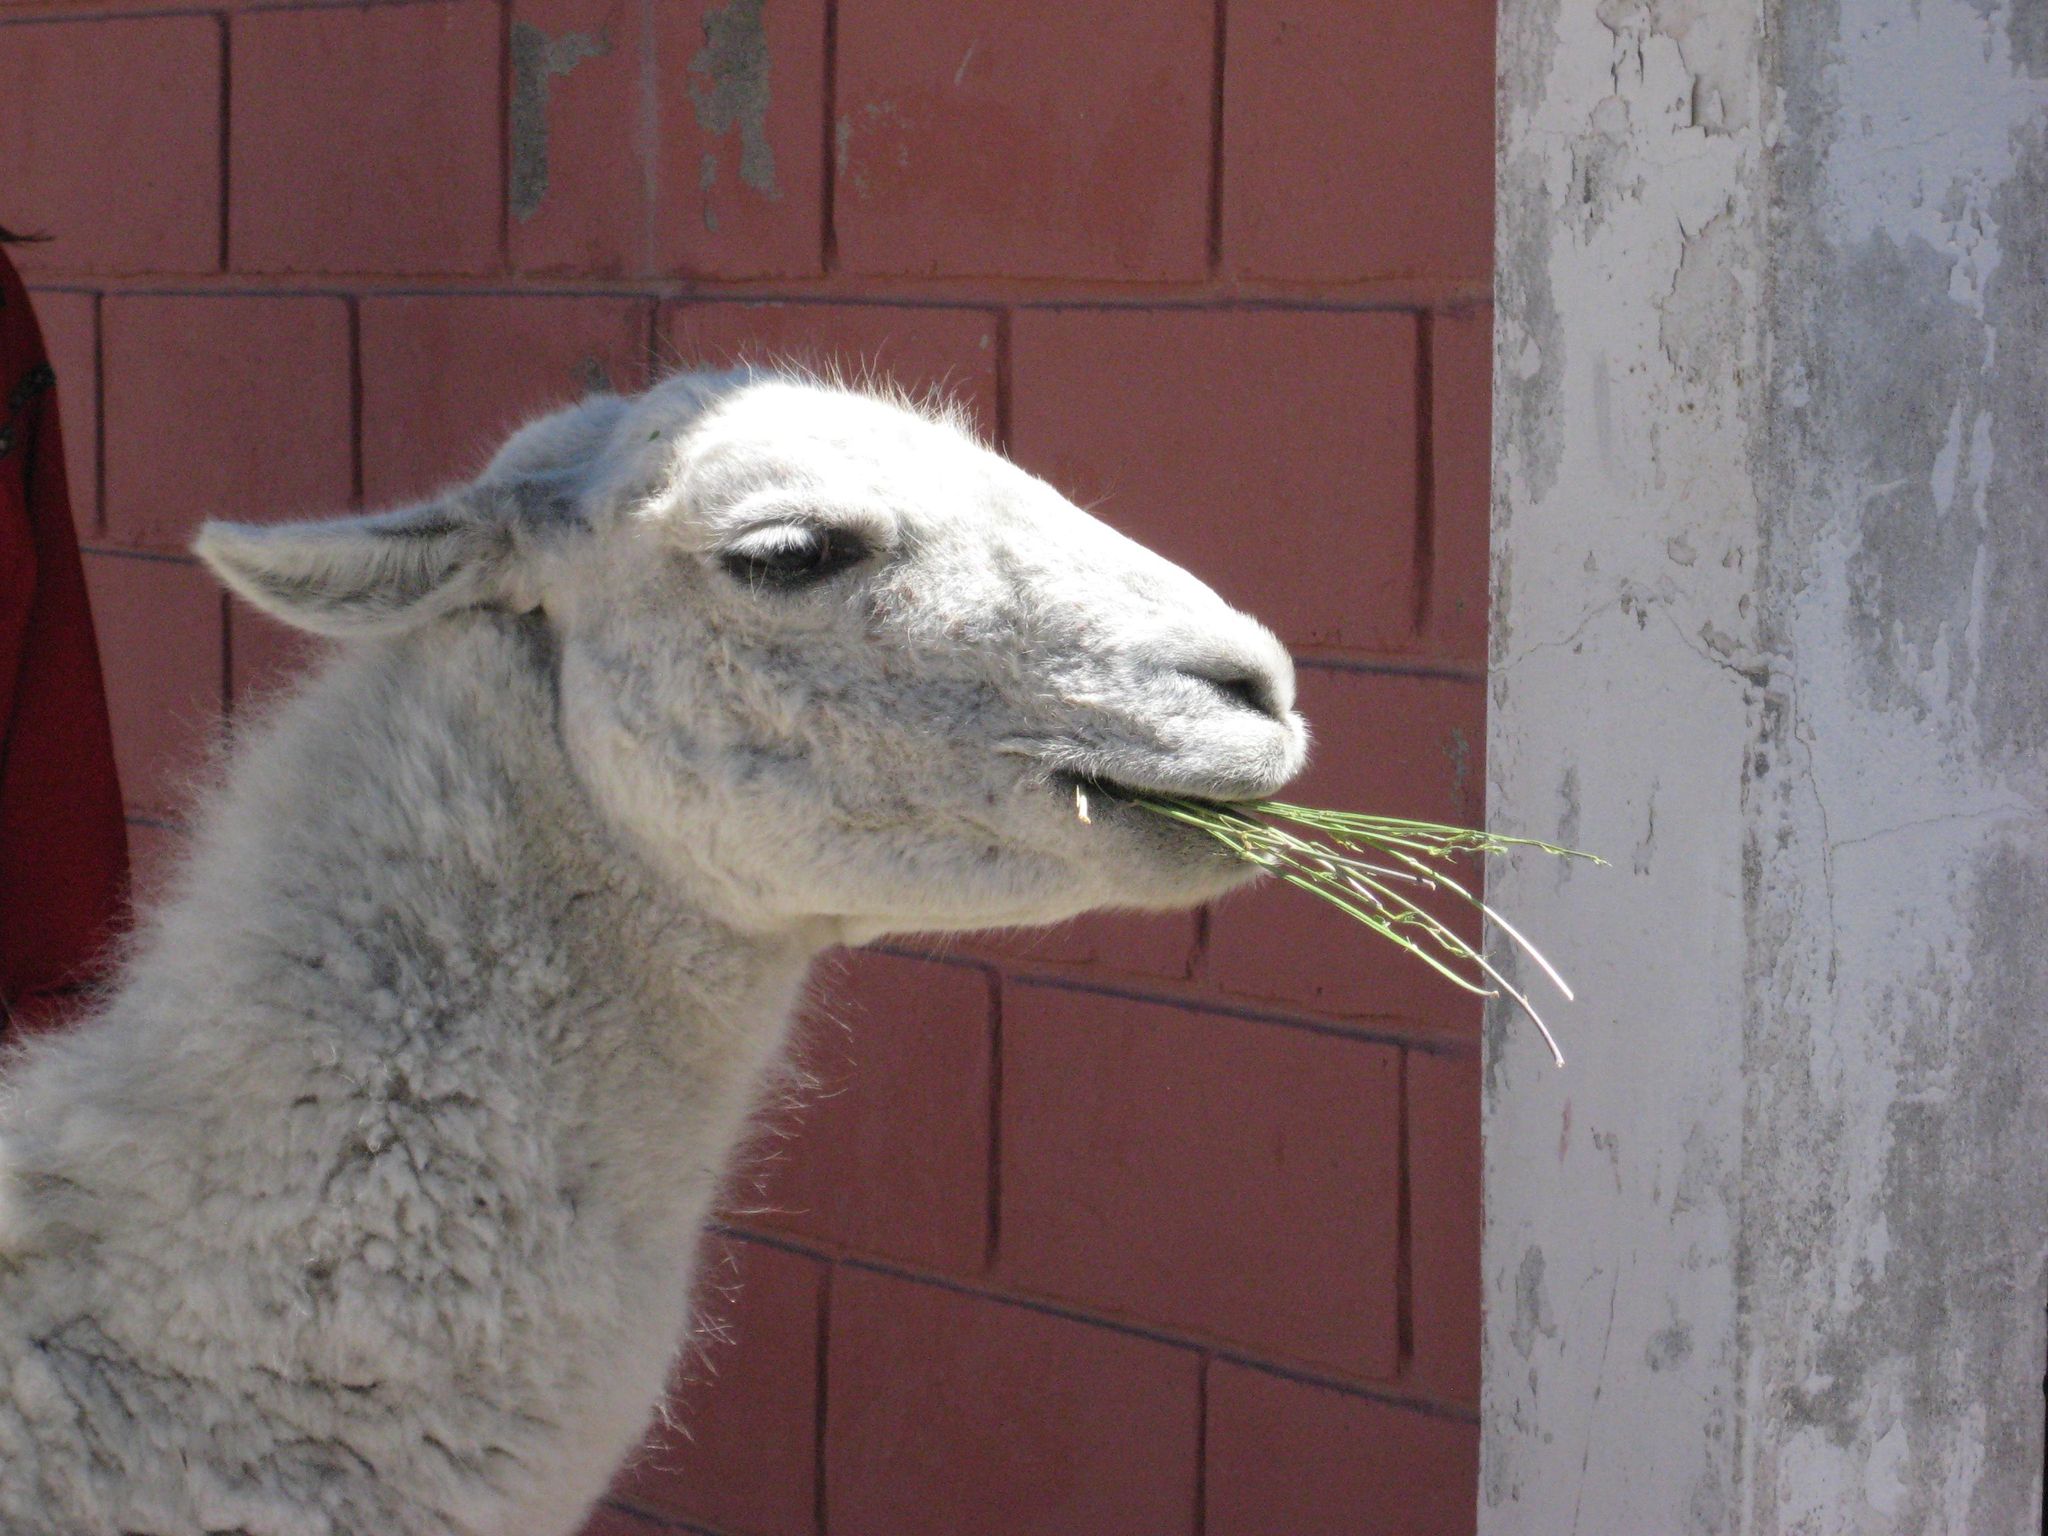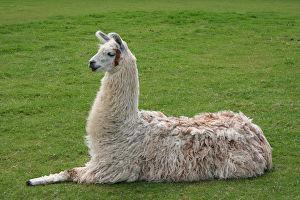The first image is the image on the left, the second image is the image on the right. For the images shown, is this caption "In one of the images, a llama has long strands of hay hanging out of its mouth." true? Answer yes or no. Yes. The first image is the image on the left, the second image is the image on the right. Analyze the images presented: Is the assertion "In at least one image there is a single brown llama eating yellow hay." valid? Answer yes or no. No. 